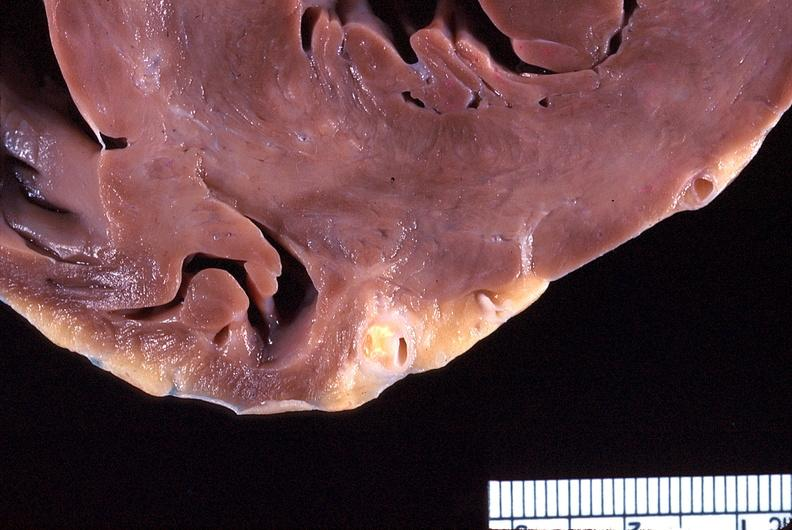s adenocarcinoma present?
Answer the question using a single word or phrase. No 